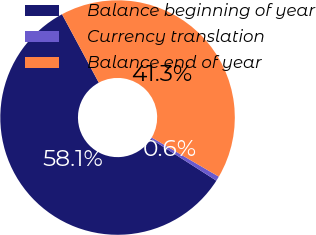Convert chart to OTSL. <chart><loc_0><loc_0><loc_500><loc_500><pie_chart><fcel>Balance beginning of year<fcel>Currency translation<fcel>Balance end of year<nl><fcel>58.1%<fcel>0.64%<fcel>41.26%<nl></chart> 